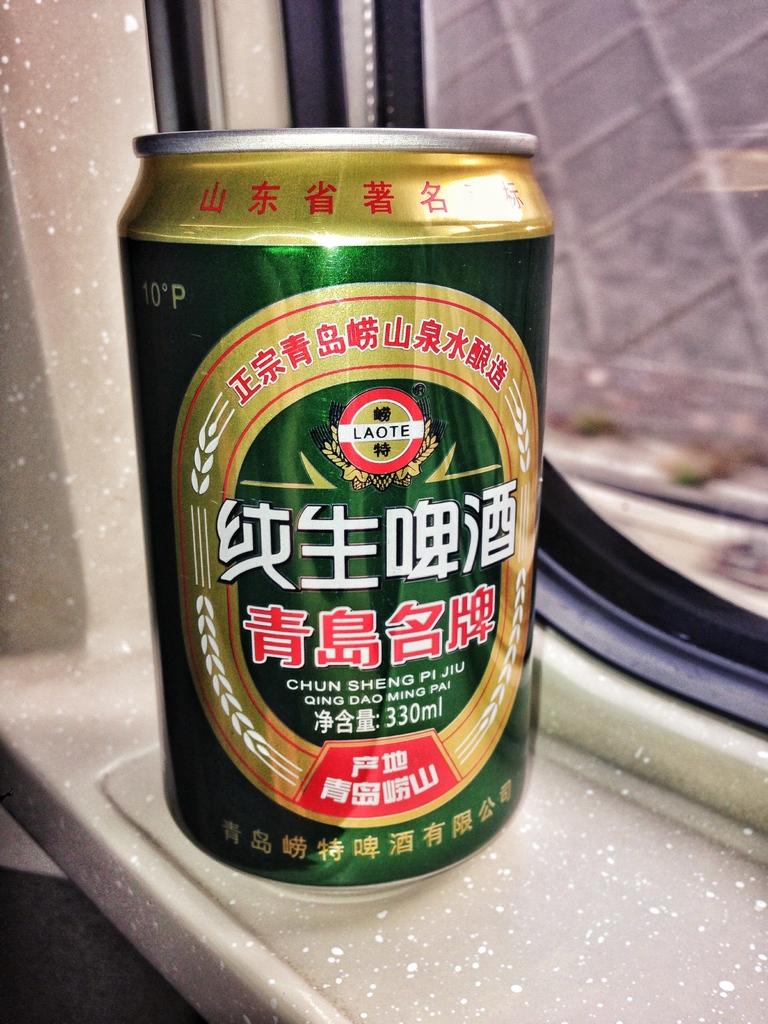How many milliliters of liquid are in this drink?
Make the answer very short. 330. 